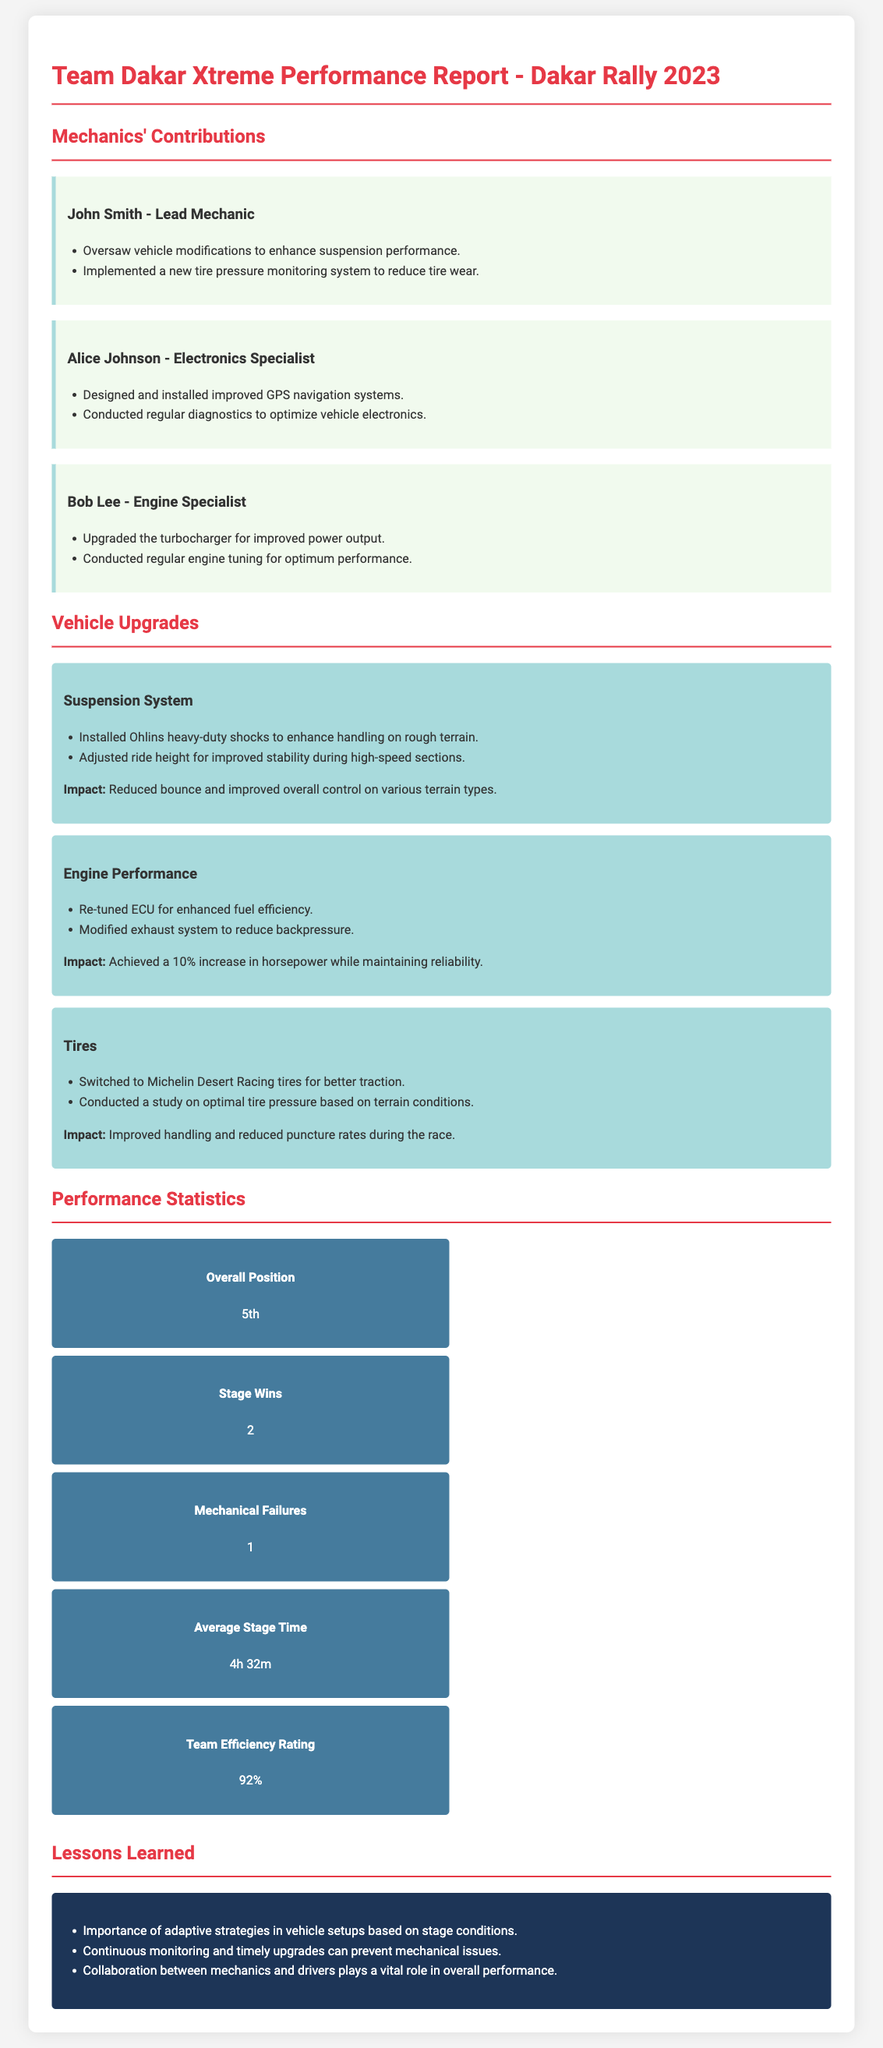What is the overall position of the team? The overall position is mentioned in the performance statistics section of the document.
Answer: 5th Who is the lead mechanic? The lead mechanic's name is listed in the mechanics' contributions section.
Answer: John Smith How many stage wins did the team achieve? The number of stage wins is stated in the performance statistics section.
Answer: 2 What was the team efficiency rating? The team efficiency rating can be found in the performance statistics section of the document.
Answer: 92% Which tires were switched to for better traction? The new tires are specified in the vehicle upgrades section.
Answer: Michelin Desert Racing tires What was the impact of the suspension system upgrade? The impact of the upgrade is described in the vehicle upgrades section.
Answer: Reduced bounce and improved overall control on various terrain types How many mechanical failures occurred during the rally? The number of mechanical failures can be found in the performance statistics section.
Answer: 1 What is one lesson learned from the season? Lessons learned are detailed towards the end of the document.
Answer: Importance of adaptive strategies in vehicle setups based on stage conditions Who designed the improved GPS navigation systems? The individual responsible for the GPS system is noted in the mechanics' contributions section.
Answer: Alice Johnson 